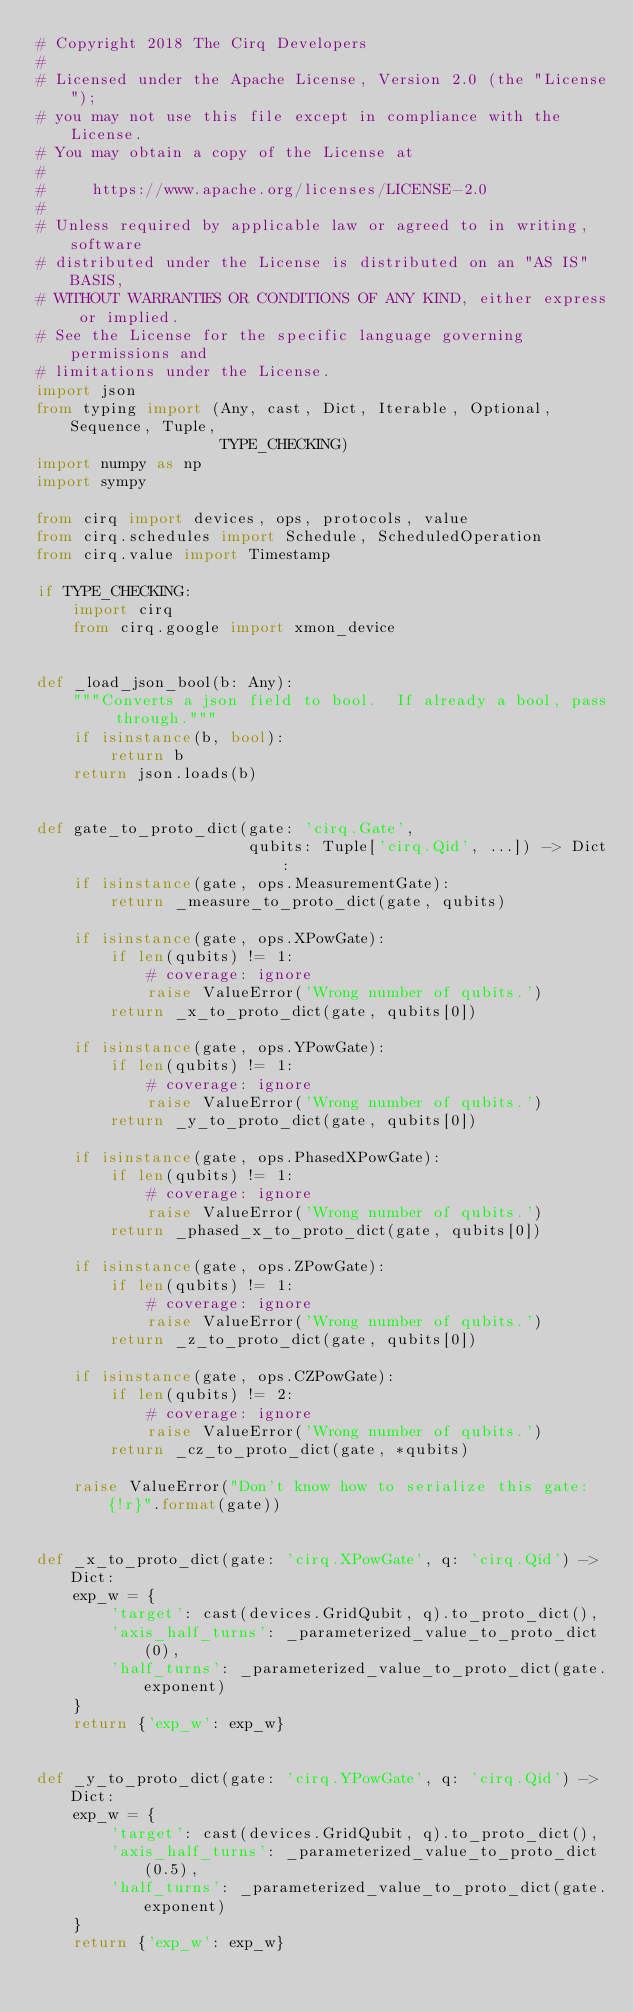Convert code to text. <code><loc_0><loc_0><loc_500><loc_500><_Python_># Copyright 2018 The Cirq Developers
#
# Licensed under the Apache License, Version 2.0 (the "License");
# you may not use this file except in compliance with the License.
# You may obtain a copy of the License at
#
#     https://www.apache.org/licenses/LICENSE-2.0
#
# Unless required by applicable law or agreed to in writing, software
# distributed under the License is distributed on an "AS IS" BASIS,
# WITHOUT WARRANTIES OR CONDITIONS OF ANY KIND, either express or implied.
# See the License for the specific language governing permissions and
# limitations under the License.
import json
from typing import (Any, cast, Dict, Iterable, Optional, Sequence, Tuple,
                    TYPE_CHECKING)
import numpy as np
import sympy

from cirq import devices, ops, protocols, value
from cirq.schedules import Schedule, ScheduledOperation
from cirq.value import Timestamp

if TYPE_CHECKING:
    import cirq
    from cirq.google import xmon_device


def _load_json_bool(b: Any):
    """Converts a json field to bool.  If already a bool, pass through."""
    if isinstance(b, bool):
        return b
    return json.loads(b)


def gate_to_proto_dict(gate: 'cirq.Gate',
                       qubits: Tuple['cirq.Qid', ...]) -> Dict:
    if isinstance(gate, ops.MeasurementGate):
        return _measure_to_proto_dict(gate, qubits)

    if isinstance(gate, ops.XPowGate):
        if len(qubits) != 1:
            # coverage: ignore
            raise ValueError('Wrong number of qubits.')
        return _x_to_proto_dict(gate, qubits[0])

    if isinstance(gate, ops.YPowGate):
        if len(qubits) != 1:
            # coverage: ignore
            raise ValueError('Wrong number of qubits.')
        return _y_to_proto_dict(gate, qubits[0])

    if isinstance(gate, ops.PhasedXPowGate):
        if len(qubits) != 1:
            # coverage: ignore
            raise ValueError('Wrong number of qubits.')
        return _phased_x_to_proto_dict(gate, qubits[0])

    if isinstance(gate, ops.ZPowGate):
        if len(qubits) != 1:
            # coverage: ignore
            raise ValueError('Wrong number of qubits.')
        return _z_to_proto_dict(gate, qubits[0])

    if isinstance(gate, ops.CZPowGate):
        if len(qubits) != 2:
            # coverage: ignore
            raise ValueError('Wrong number of qubits.')
        return _cz_to_proto_dict(gate, *qubits)

    raise ValueError("Don't know how to serialize this gate: {!r}".format(gate))


def _x_to_proto_dict(gate: 'cirq.XPowGate', q: 'cirq.Qid') -> Dict:
    exp_w = {
        'target': cast(devices.GridQubit, q).to_proto_dict(),
        'axis_half_turns': _parameterized_value_to_proto_dict(0),
        'half_turns': _parameterized_value_to_proto_dict(gate.exponent)
    }
    return {'exp_w': exp_w}


def _y_to_proto_dict(gate: 'cirq.YPowGate', q: 'cirq.Qid') -> Dict:
    exp_w = {
        'target': cast(devices.GridQubit, q).to_proto_dict(),
        'axis_half_turns': _parameterized_value_to_proto_dict(0.5),
        'half_turns': _parameterized_value_to_proto_dict(gate.exponent)
    }
    return {'exp_w': exp_w}

</code> 